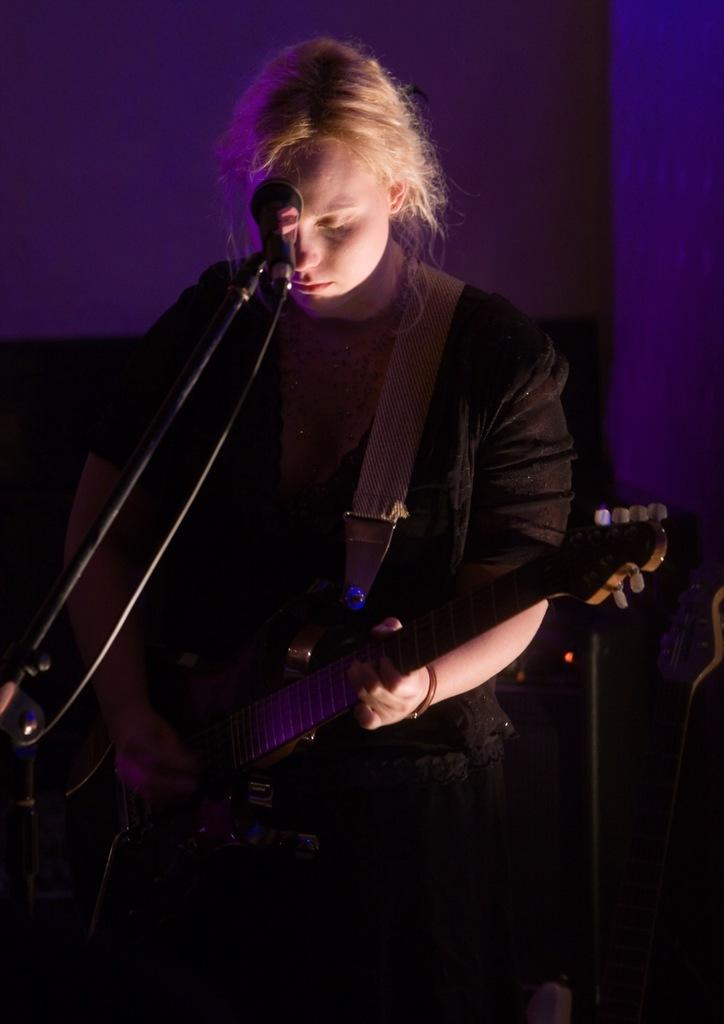Who is the main subject in the image? There is a woman in the image. What is the woman holding in the image? The woman is holding a guitar. What is the woman doing with the guitar? The woman is playing the guitar. What other object related to music can be seen in the image? There is a microphone in the image. How is the microphone positioned in the image? The microphone is attached to a stand. Can you see a tiger playing the guitar in the image? No, there is no tiger present in the image. What book is the woman reading while playing the guitar? There is no book visible in the image; the woman is focused on playing the guitar. 